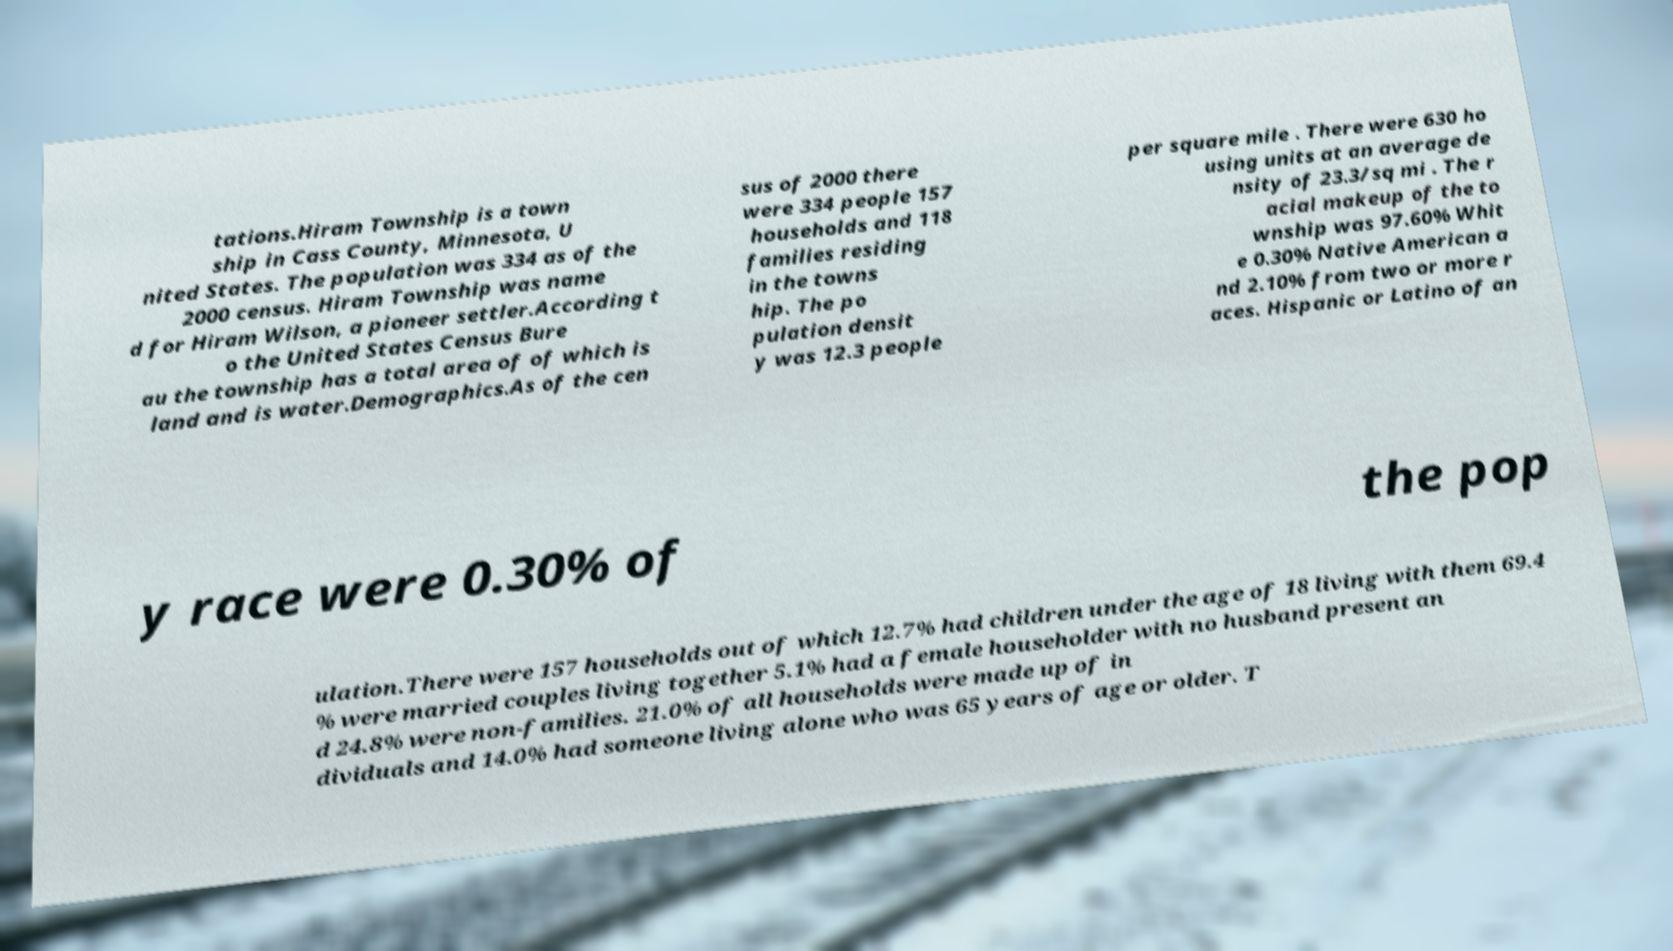For documentation purposes, I need the text within this image transcribed. Could you provide that? tations.Hiram Township is a town ship in Cass County, Minnesota, U nited States. The population was 334 as of the 2000 census. Hiram Township was name d for Hiram Wilson, a pioneer settler.According t o the United States Census Bure au the township has a total area of of which is land and is water.Demographics.As of the cen sus of 2000 there were 334 people 157 households and 118 families residing in the towns hip. The po pulation densit y was 12.3 people per square mile . There were 630 ho using units at an average de nsity of 23.3/sq mi . The r acial makeup of the to wnship was 97.60% Whit e 0.30% Native American a nd 2.10% from two or more r aces. Hispanic or Latino of an y race were 0.30% of the pop ulation.There were 157 households out of which 12.7% had children under the age of 18 living with them 69.4 % were married couples living together 5.1% had a female householder with no husband present an d 24.8% were non-families. 21.0% of all households were made up of in dividuals and 14.0% had someone living alone who was 65 years of age or older. T 